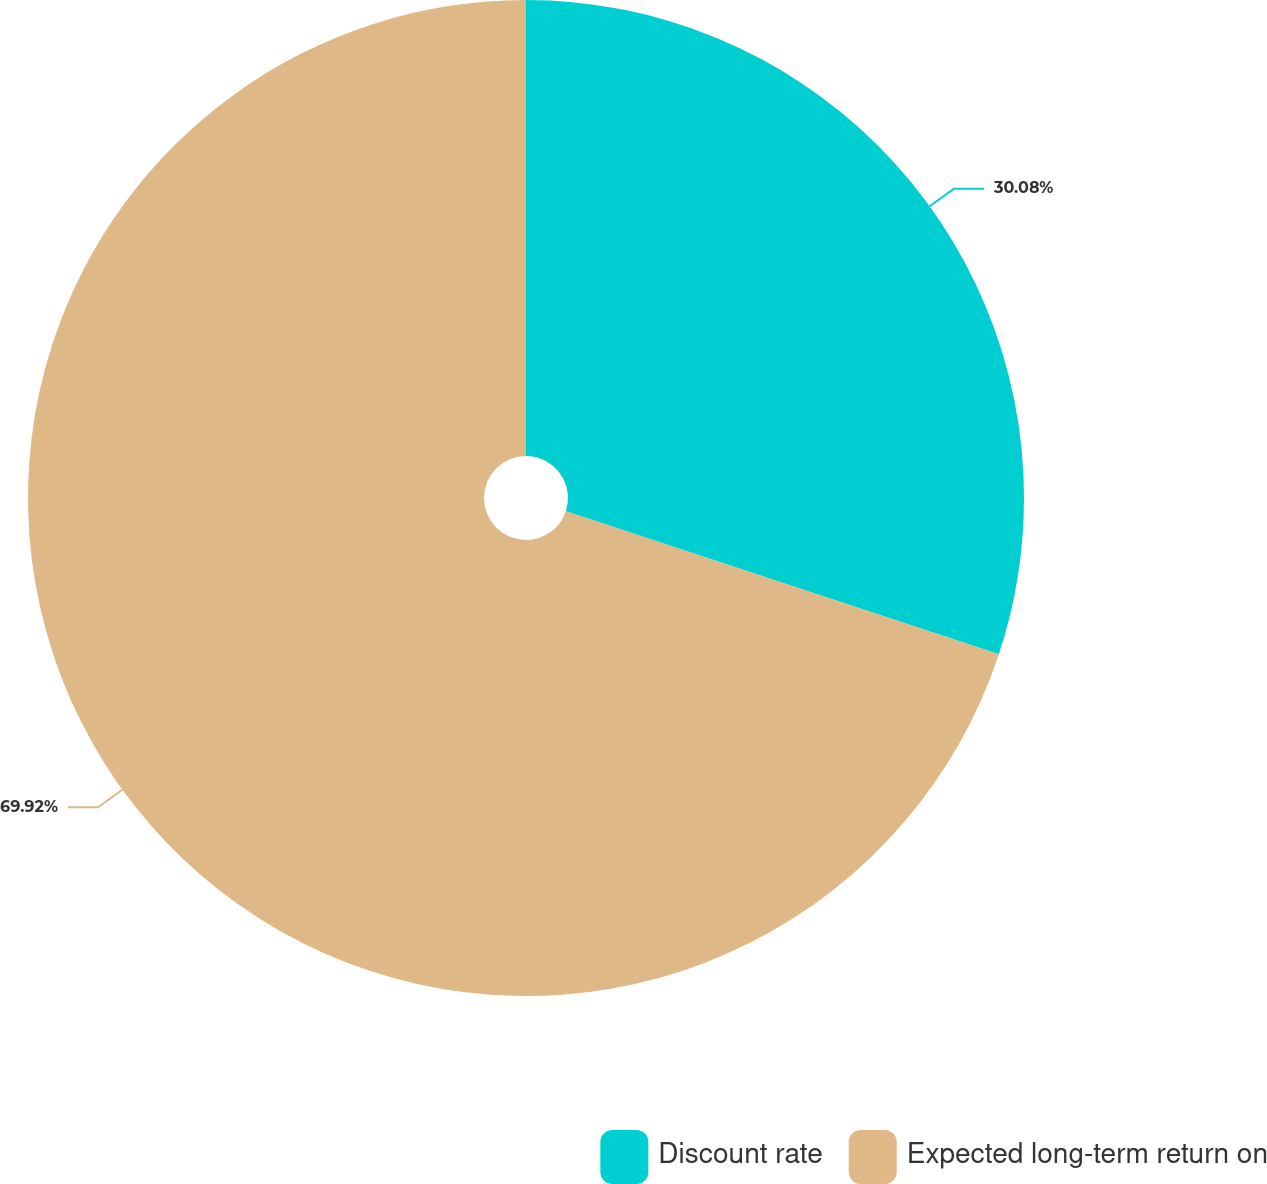Convert chart. <chart><loc_0><loc_0><loc_500><loc_500><pie_chart><fcel>Discount rate<fcel>Expected long-term return on<nl><fcel>30.08%<fcel>69.92%<nl></chart> 